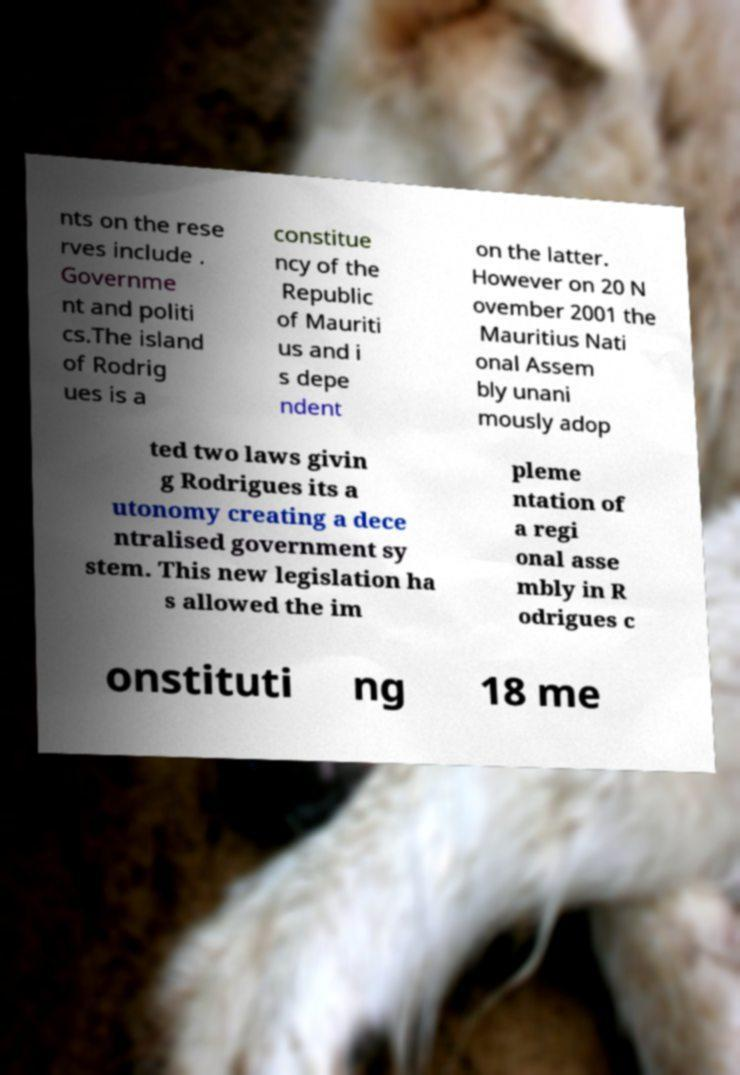There's text embedded in this image that I need extracted. Can you transcribe it verbatim? nts on the rese rves include . Governme nt and politi cs.The island of Rodrig ues is a constitue ncy of the Republic of Mauriti us and i s depe ndent on the latter. However on 20 N ovember 2001 the Mauritius Nati onal Assem bly unani mously adop ted two laws givin g Rodrigues its a utonomy creating a dece ntralised government sy stem. This new legislation ha s allowed the im pleme ntation of a regi onal asse mbly in R odrigues c onstituti ng 18 me 